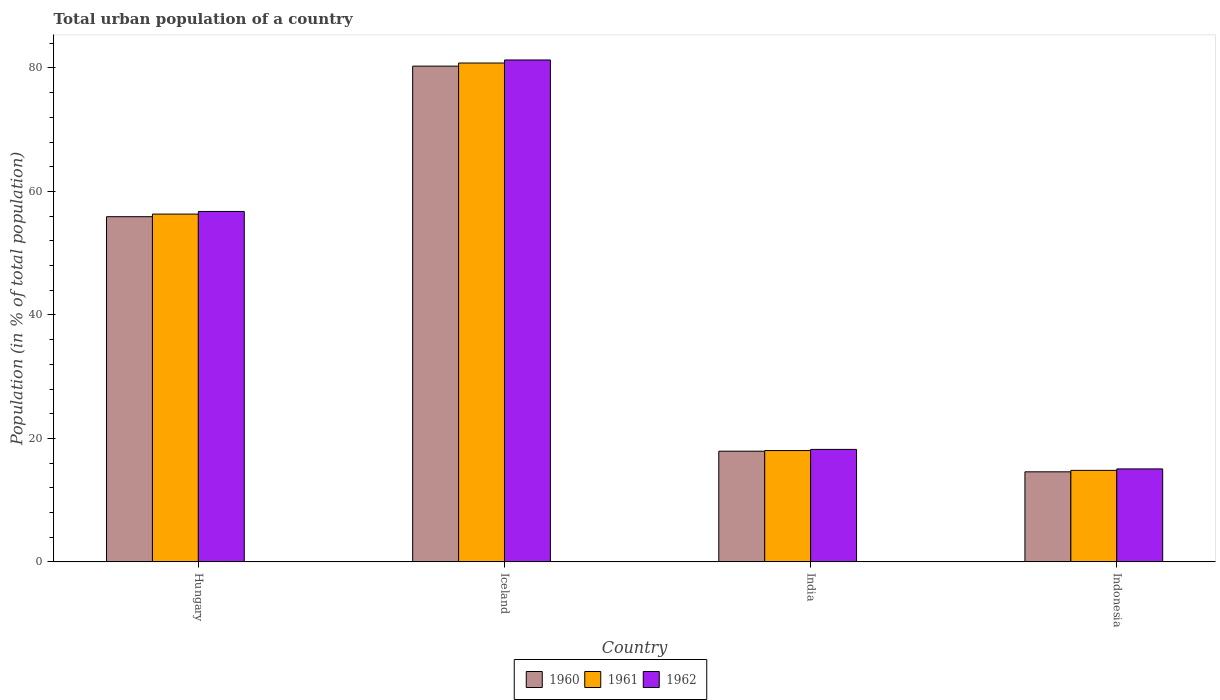Are the number of bars per tick equal to the number of legend labels?
Your response must be concise. Yes. What is the urban population in 1960 in Hungary?
Your answer should be compact. 55.91. Across all countries, what is the maximum urban population in 1961?
Make the answer very short. 80.8. Across all countries, what is the minimum urban population in 1960?
Provide a short and direct response. 14.59. What is the total urban population in 1962 in the graph?
Ensure brevity in your answer.  171.33. What is the difference between the urban population in 1962 in India and that in Indonesia?
Keep it short and to the point. 3.16. What is the difference between the urban population in 1961 in Indonesia and the urban population in 1960 in Iceland?
Your response must be concise. -65.48. What is the average urban population in 1961 per country?
Provide a succinct answer. 42.5. What is the difference between the urban population of/in 1961 and urban population of/in 1962 in India?
Your answer should be compact. -0.19. In how many countries, is the urban population in 1961 greater than 12 %?
Provide a short and direct response. 4. What is the ratio of the urban population in 1960 in Iceland to that in India?
Offer a terse response. 4.48. What is the difference between the highest and the second highest urban population in 1960?
Give a very brief answer. 62.38. What is the difference between the highest and the lowest urban population in 1960?
Ensure brevity in your answer.  65.71. What does the 2nd bar from the left in Indonesia represents?
Make the answer very short. 1961. What does the 1st bar from the right in Indonesia represents?
Your answer should be compact. 1962. Is it the case that in every country, the sum of the urban population in 1962 and urban population in 1960 is greater than the urban population in 1961?
Provide a succinct answer. Yes. Are all the bars in the graph horizontal?
Give a very brief answer. No. How many legend labels are there?
Ensure brevity in your answer.  3. What is the title of the graph?
Your answer should be very brief. Total urban population of a country. What is the label or title of the X-axis?
Offer a very short reply. Country. What is the label or title of the Y-axis?
Your response must be concise. Population (in % of total population). What is the Population (in % of total population) in 1960 in Hungary?
Offer a very short reply. 55.91. What is the Population (in % of total population) in 1961 in Hungary?
Your response must be concise. 56.34. What is the Population (in % of total population) in 1962 in Hungary?
Your answer should be compact. 56.76. What is the Population (in % of total population) in 1960 in Iceland?
Ensure brevity in your answer.  80.3. What is the Population (in % of total population) in 1961 in Iceland?
Provide a succinct answer. 80.8. What is the Population (in % of total population) in 1962 in Iceland?
Your answer should be compact. 81.3. What is the Population (in % of total population) in 1960 in India?
Provide a succinct answer. 17.92. What is the Population (in % of total population) in 1961 in India?
Keep it short and to the point. 18.03. What is the Population (in % of total population) in 1962 in India?
Your answer should be very brief. 18.22. What is the Population (in % of total population) of 1960 in Indonesia?
Keep it short and to the point. 14.59. What is the Population (in % of total population) in 1961 in Indonesia?
Give a very brief answer. 14.82. What is the Population (in % of total population) in 1962 in Indonesia?
Provide a short and direct response. 15.06. Across all countries, what is the maximum Population (in % of total population) of 1960?
Provide a succinct answer. 80.3. Across all countries, what is the maximum Population (in % of total population) in 1961?
Keep it short and to the point. 80.8. Across all countries, what is the maximum Population (in % of total population) in 1962?
Keep it short and to the point. 81.3. Across all countries, what is the minimum Population (in % of total population) of 1960?
Ensure brevity in your answer.  14.59. Across all countries, what is the minimum Population (in % of total population) in 1961?
Your answer should be very brief. 14.82. Across all countries, what is the minimum Population (in % of total population) of 1962?
Provide a succinct answer. 15.06. What is the total Population (in % of total population) of 1960 in the graph?
Your answer should be compact. 168.72. What is the total Population (in % of total population) in 1961 in the graph?
Keep it short and to the point. 169.99. What is the total Population (in % of total population) in 1962 in the graph?
Offer a very short reply. 171.33. What is the difference between the Population (in % of total population) in 1960 in Hungary and that in Iceland?
Offer a very short reply. -24.39. What is the difference between the Population (in % of total population) in 1961 in Hungary and that in Iceland?
Provide a short and direct response. -24.47. What is the difference between the Population (in % of total population) in 1962 in Hungary and that in Iceland?
Keep it short and to the point. -24.54. What is the difference between the Population (in % of total population) in 1960 in Hungary and that in India?
Your answer should be compact. 37.99. What is the difference between the Population (in % of total population) in 1961 in Hungary and that in India?
Offer a very short reply. 38.3. What is the difference between the Population (in % of total population) of 1962 in Hungary and that in India?
Your response must be concise. 38.54. What is the difference between the Population (in % of total population) in 1960 in Hungary and that in Indonesia?
Keep it short and to the point. 41.33. What is the difference between the Population (in % of total population) in 1961 in Hungary and that in Indonesia?
Provide a short and direct response. 41.51. What is the difference between the Population (in % of total population) in 1962 in Hungary and that in Indonesia?
Offer a very short reply. 41.7. What is the difference between the Population (in % of total population) in 1960 in Iceland and that in India?
Your response must be concise. 62.38. What is the difference between the Population (in % of total population) of 1961 in Iceland and that in India?
Provide a short and direct response. 62.77. What is the difference between the Population (in % of total population) of 1962 in Iceland and that in India?
Your answer should be very brief. 63.08. What is the difference between the Population (in % of total population) of 1960 in Iceland and that in Indonesia?
Offer a terse response. 65.71. What is the difference between the Population (in % of total population) of 1961 in Iceland and that in Indonesia?
Provide a short and direct response. 65.98. What is the difference between the Population (in % of total population) in 1962 in Iceland and that in Indonesia?
Provide a succinct answer. 66.24. What is the difference between the Population (in % of total population) in 1960 in India and that in Indonesia?
Provide a succinct answer. 3.34. What is the difference between the Population (in % of total population) in 1961 in India and that in Indonesia?
Ensure brevity in your answer.  3.21. What is the difference between the Population (in % of total population) of 1962 in India and that in Indonesia?
Give a very brief answer. 3.16. What is the difference between the Population (in % of total population) of 1960 in Hungary and the Population (in % of total population) of 1961 in Iceland?
Make the answer very short. -24.89. What is the difference between the Population (in % of total population) of 1960 in Hungary and the Population (in % of total population) of 1962 in Iceland?
Ensure brevity in your answer.  -25.39. What is the difference between the Population (in % of total population) in 1961 in Hungary and the Population (in % of total population) in 1962 in Iceland?
Your response must be concise. -24.96. What is the difference between the Population (in % of total population) of 1960 in Hungary and the Population (in % of total population) of 1961 in India?
Keep it short and to the point. 37.88. What is the difference between the Population (in % of total population) of 1960 in Hungary and the Population (in % of total population) of 1962 in India?
Make the answer very short. 37.69. What is the difference between the Population (in % of total population) in 1961 in Hungary and the Population (in % of total population) in 1962 in India?
Your answer should be compact. 38.12. What is the difference between the Population (in % of total population) in 1960 in Hungary and the Population (in % of total population) in 1961 in Indonesia?
Your answer should be compact. 41.09. What is the difference between the Population (in % of total population) of 1960 in Hungary and the Population (in % of total population) of 1962 in Indonesia?
Provide a short and direct response. 40.85. What is the difference between the Population (in % of total population) of 1961 in Hungary and the Population (in % of total population) of 1962 in Indonesia?
Keep it short and to the point. 41.28. What is the difference between the Population (in % of total population) of 1960 in Iceland and the Population (in % of total population) of 1961 in India?
Your answer should be compact. 62.27. What is the difference between the Population (in % of total population) of 1960 in Iceland and the Population (in % of total population) of 1962 in India?
Keep it short and to the point. 62.08. What is the difference between the Population (in % of total population) of 1961 in Iceland and the Population (in % of total population) of 1962 in India?
Provide a succinct answer. 62.59. What is the difference between the Population (in % of total population) of 1960 in Iceland and the Population (in % of total population) of 1961 in Indonesia?
Offer a terse response. 65.48. What is the difference between the Population (in % of total population) of 1960 in Iceland and the Population (in % of total population) of 1962 in Indonesia?
Your answer should be very brief. 65.24. What is the difference between the Population (in % of total population) in 1961 in Iceland and the Population (in % of total population) in 1962 in Indonesia?
Your answer should be very brief. 65.75. What is the difference between the Population (in % of total population) of 1960 in India and the Population (in % of total population) of 1961 in Indonesia?
Provide a short and direct response. 3.1. What is the difference between the Population (in % of total population) of 1960 in India and the Population (in % of total population) of 1962 in Indonesia?
Give a very brief answer. 2.87. What is the difference between the Population (in % of total population) in 1961 in India and the Population (in % of total population) in 1962 in Indonesia?
Your answer should be compact. 2.97. What is the average Population (in % of total population) of 1960 per country?
Provide a short and direct response. 42.18. What is the average Population (in % of total population) in 1961 per country?
Make the answer very short. 42.5. What is the average Population (in % of total population) in 1962 per country?
Your answer should be very brief. 42.83. What is the difference between the Population (in % of total population) in 1960 and Population (in % of total population) in 1961 in Hungary?
Offer a very short reply. -0.42. What is the difference between the Population (in % of total population) of 1960 and Population (in % of total population) of 1962 in Hungary?
Offer a terse response. -0.85. What is the difference between the Population (in % of total population) in 1961 and Population (in % of total population) in 1962 in Hungary?
Provide a succinct answer. -0.42. What is the difference between the Population (in % of total population) of 1960 and Population (in % of total population) of 1961 in Iceland?
Offer a terse response. -0.5. What is the difference between the Population (in % of total population) in 1960 and Population (in % of total population) in 1962 in Iceland?
Offer a very short reply. -1. What is the difference between the Population (in % of total population) of 1961 and Population (in % of total population) of 1962 in Iceland?
Ensure brevity in your answer.  -0.49. What is the difference between the Population (in % of total population) of 1960 and Population (in % of total population) of 1961 in India?
Ensure brevity in your answer.  -0.11. What is the difference between the Population (in % of total population) of 1960 and Population (in % of total population) of 1962 in India?
Your response must be concise. -0.29. What is the difference between the Population (in % of total population) in 1961 and Population (in % of total population) in 1962 in India?
Give a very brief answer. -0.19. What is the difference between the Population (in % of total population) of 1960 and Population (in % of total population) of 1961 in Indonesia?
Give a very brief answer. -0.23. What is the difference between the Population (in % of total population) in 1960 and Population (in % of total population) in 1962 in Indonesia?
Provide a succinct answer. -0.47. What is the difference between the Population (in % of total population) of 1961 and Population (in % of total population) of 1962 in Indonesia?
Your response must be concise. -0.24. What is the ratio of the Population (in % of total population) of 1960 in Hungary to that in Iceland?
Offer a terse response. 0.7. What is the ratio of the Population (in % of total population) in 1961 in Hungary to that in Iceland?
Your answer should be very brief. 0.7. What is the ratio of the Population (in % of total population) of 1962 in Hungary to that in Iceland?
Ensure brevity in your answer.  0.7. What is the ratio of the Population (in % of total population) in 1960 in Hungary to that in India?
Provide a short and direct response. 3.12. What is the ratio of the Population (in % of total population) in 1961 in Hungary to that in India?
Offer a terse response. 3.12. What is the ratio of the Population (in % of total population) of 1962 in Hungary to that in India?
Ensure brevity in your answer.  3.12. What is the ratio of the Population (in % of total population) in 1960 in Hungary to that in Indonesia?
Give a very brief answer. 3.83. What is the ratio of the Population (in % of total population) in 1961 in Hungary to that in Indonesia?
Provide a short and direct response. 3.8. What is the ratio of the Population (in % of total population) in 1962 in Hungary to that in Indonesia?
Provide a short and direct response. 3.77. What is the ratio of the Population (in % of total population) in 1960 in Iceland to that in India?
Offer a terse response. 4.48. What is the ratio of the Population (in % of total population) in 1961 in Iceland to that in India?
Give a very brief answer. 4.48. What is the ratio of the Population (in % of total population) of 1962 in Iceland to that in India?
Offer a very short reply. 4.46. What is the ratio of the Population (in % of total population) in 1960 in Iceland to that in Indonesia?
Keep it short and to the point. 5.51. What is the ratio of the Population (in % of total population) of 1961 in Iceland to that in Indonesia?
Your answer should be very brief. 5.45. What is the ratio of the Population (in % of total population) in 1962 in Iceland to that in Indonesia?
Your response must be concise. 5.4. What is the ratio of the Population (in % of total population) of 1960 in India to that in Indonesia?
Keep it short and to the point. 1.23. What is the ratio of the Population (in % of total population) in 1961 in India to that in Indonesia?
Provide a short and direct response. 1.22. What is the ratio of the Population (in % of total population) in 1962 in India to that in Indonesia?
Provide a succinct answer. 1.21. What is the difference between the highest and the second highest Population (in % of total population) of 1960?
Provide a succinct answer. 24.39. What is the difference between the highest and the second highest Population (in % of total population) of 1961?
Give a very brief answer. 24.47. What is the difference between the highest and the second highest Population (in % of total population) of 1962?
Provide a succinct answer. 24.54. What is the difference between the highest and the lowest Population (in % of total population) of 1960?
Keep it short and to the point. 65.71. What is the difference between the highest and the lowest Population (in % of total population) of 1961?
Your answer should be very brief. 65.98. What is the difference between the highest and the lowest Population (in % of total population) in 1962?
Your answer should be compact. 66.24. 